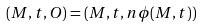<formula> <loc_0><loc_0><loc_500><loc_500>( M , t , O ) = ( M , t , n \phi ( M , t ) )</formula> 